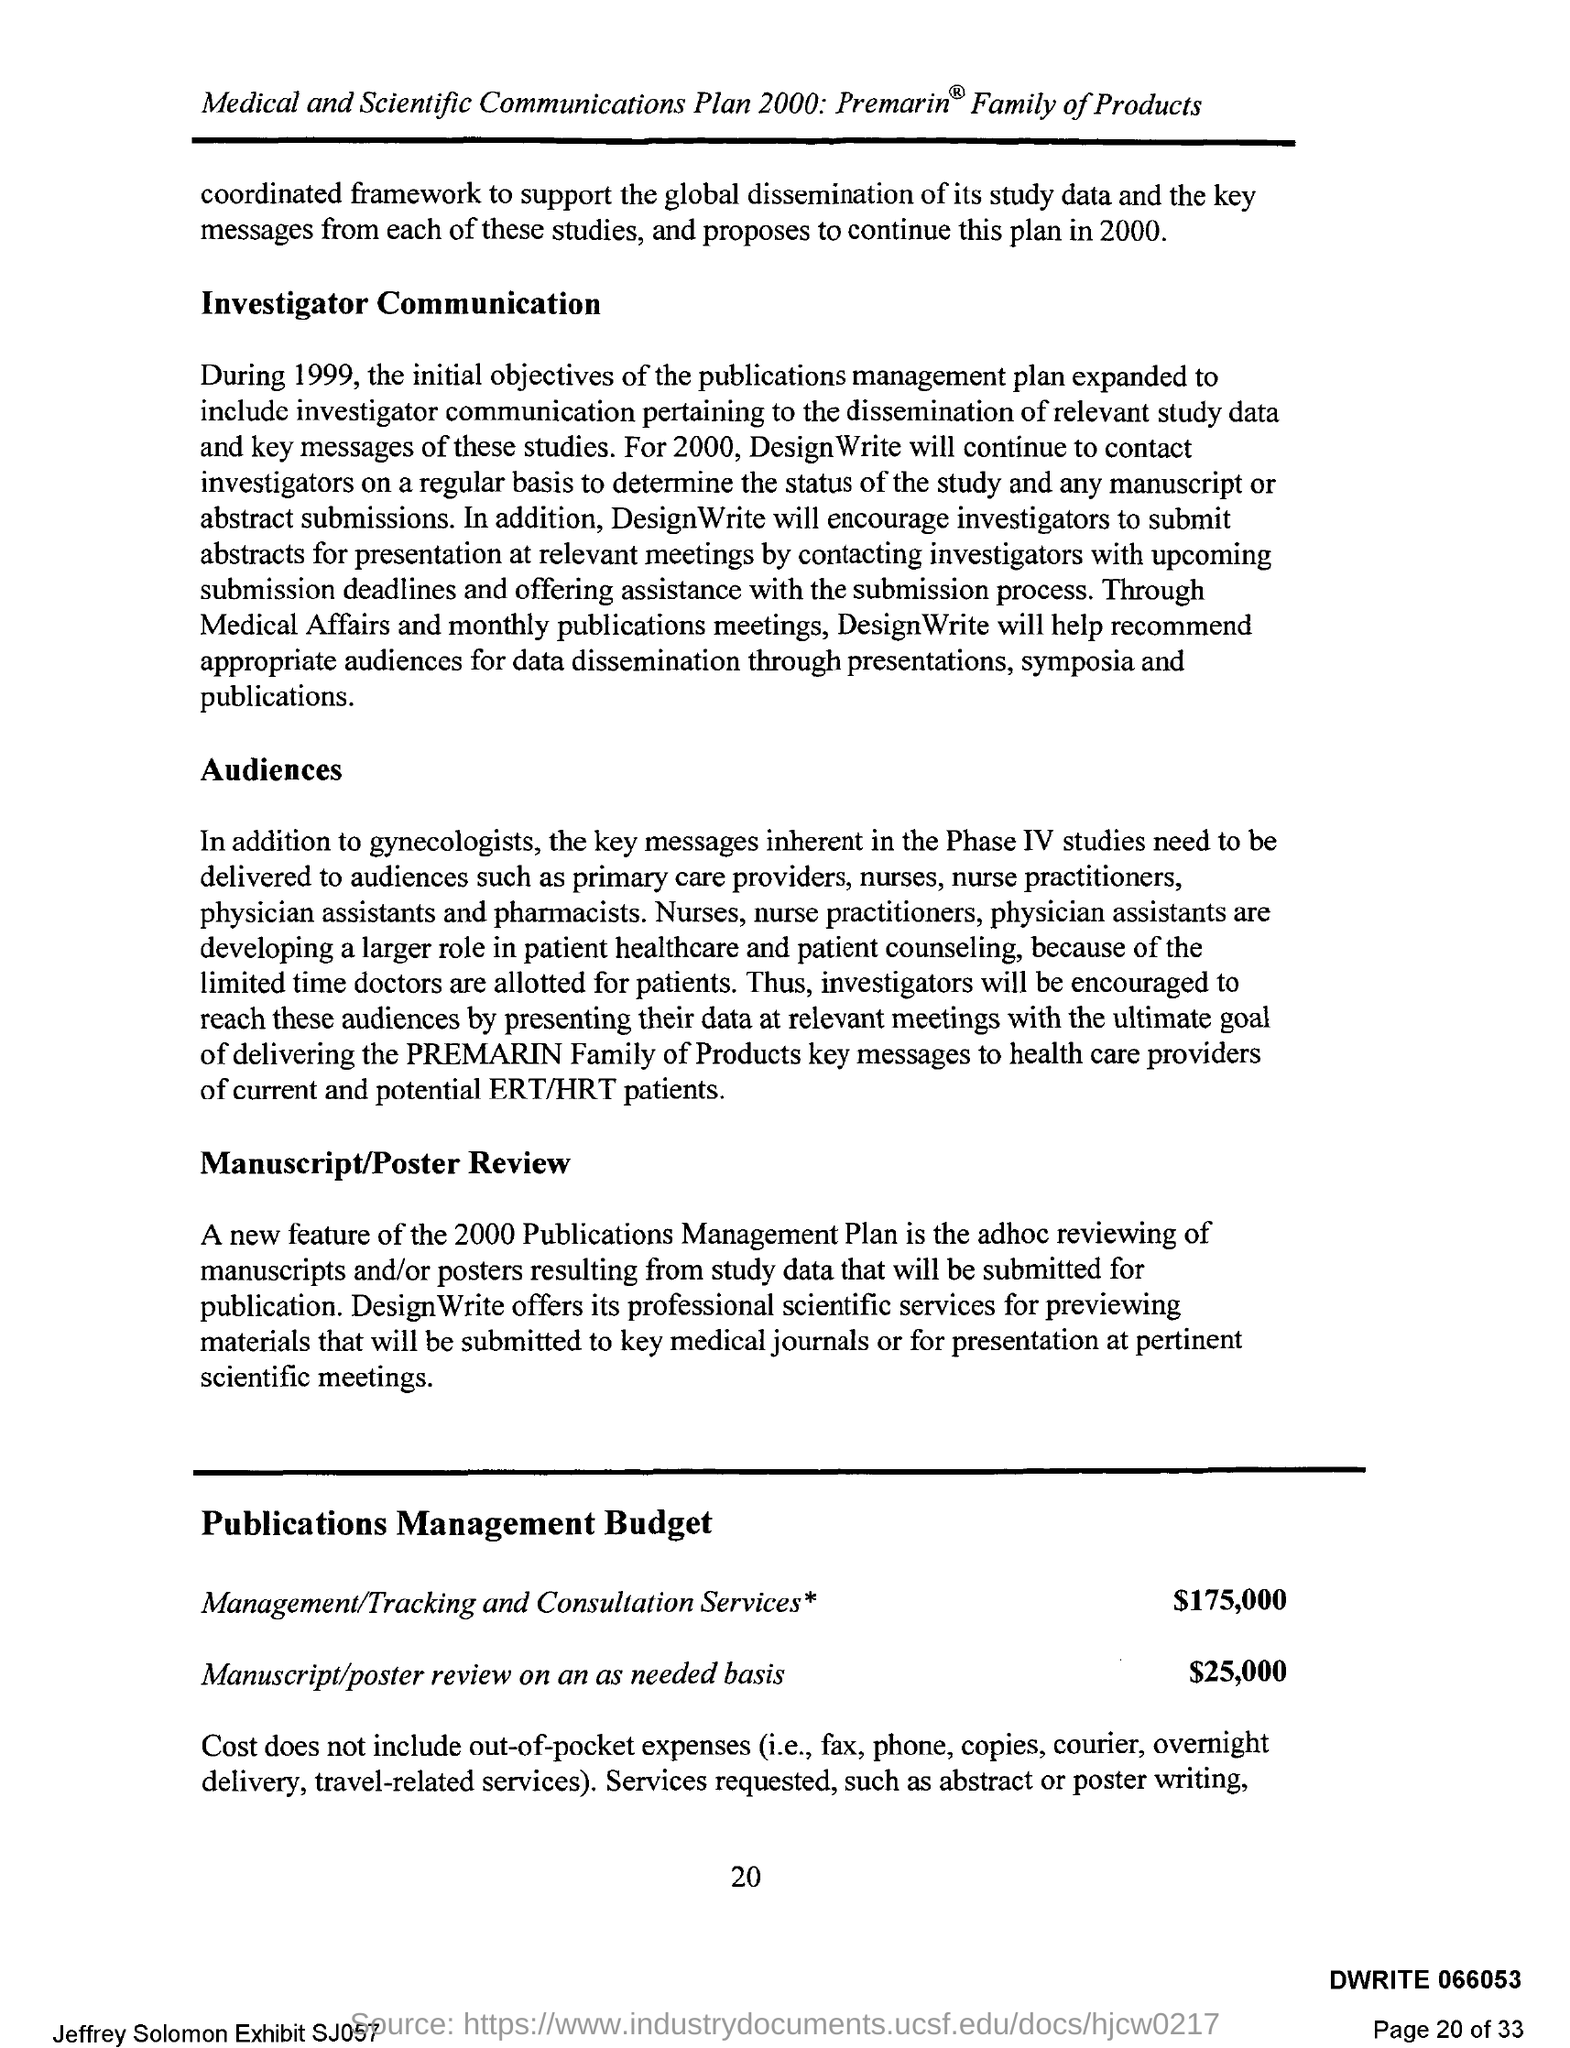What is the Page Number?
Your response must be concise. 20. What is the budget for Manuscript/poster review on an as-needed basis?
Provide a short and direct response. $25,000. What is the budget for Management and Consultation services?
Your answer should be compact. $175,000. 